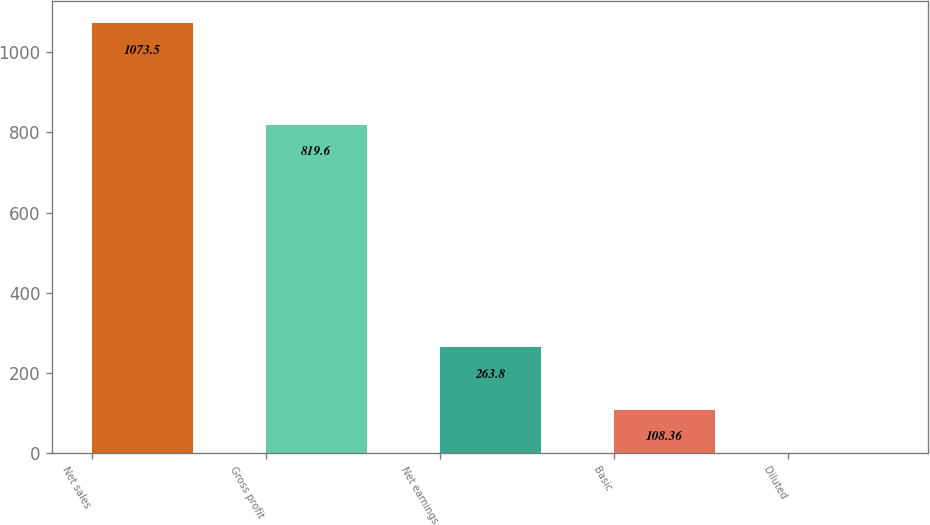Convert chart. <chart><loc_0><loc_0><loc_500><loc_500><bar_chart><fcel>Net sales<fcel>Gross profit<fcel>Net earnings<fcel>Basic<fcel>Diluted<nl><fcel>1073.5<fcel>819.6<fcel>263.8<fcel>108.36<fcel>1.12<nl></chart> 